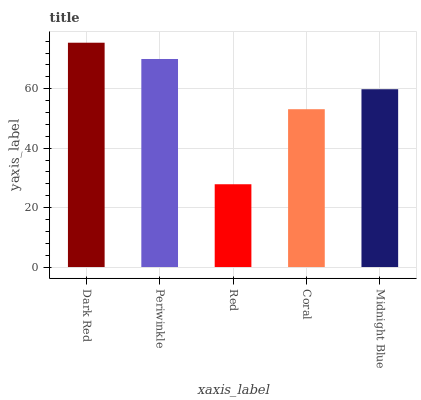Is Red the minimum?
Answer yes or no. Yes. Is Dark Red the maximum?
Answer yes or no. Yes. Is Periwinkle the minimum?
Answer yes or no. No. Is Periwinkle the maximum?
Answer yes or no. No. Is Dark Red greater than Periwinkle?
Answer yes or no. Yes. Is Periwinkle less than Dark Red?
Answer yes or no. Yes. Is Periwinkle greater than Dark Red?
Answer yes or no. No. Is Dark Red less than Periwinkle?
Answer yes or no. No. Is Midnight Blue the high median?
Answer yes or no. Yes. Is Midnight Blue the low median?
Answer yes or no. Yes. Is Dark Red the high median?
Answer yes or no. No. Is Dark Red the low median?
Answer yes or no. No. 